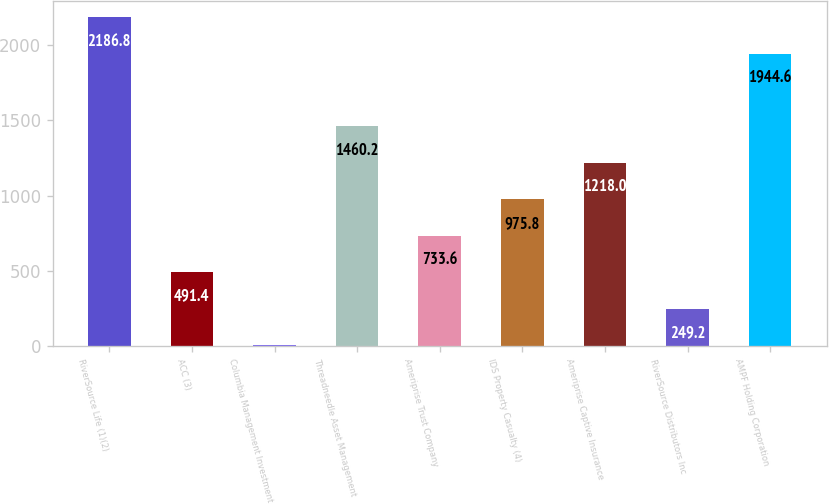Convert chart to OTSL. <chart><loc_0><loc_0><loc_500><loc_500><bar_chart><fcel>RiverSource Life (1)(2)<fcel>ACC (3)<fcel>Columbia Management Investment<fcel>Threadneedle Asset Management<fcel>Ameriprise Trust Company<fcel>IDS Property Casualty (4)<fcel>Ameriprise Captive Insurance<fcel>RiverSource Distributors Inc<fcel>AMPF Holding Corporation<nl><fcel>2186.8<fcel>491.4<fcel>7<fcel>1460.2<fcel>733.6<fcel>975.8<fcel>1218<fcel>249.2<fcel>1944.6<nl></chart> 